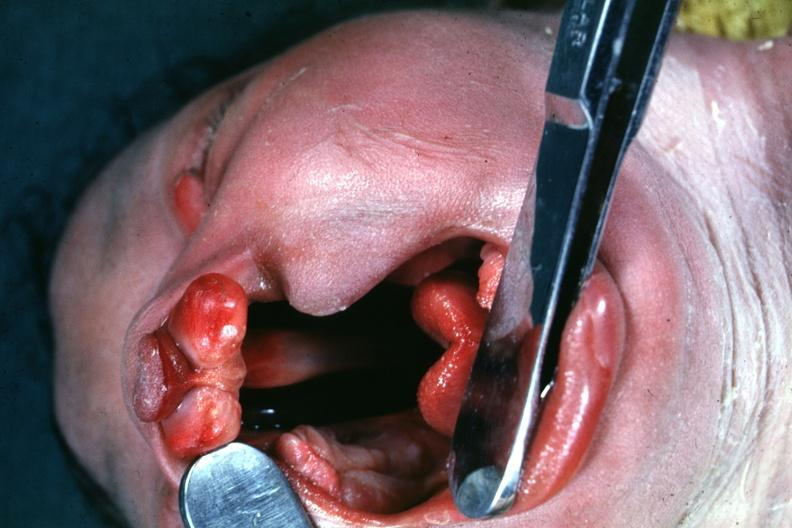s newborn cord around neck present?
Answer the question using a single word or phrase. No 